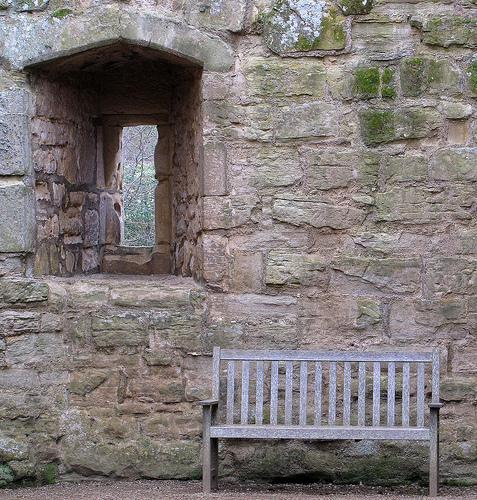Question: what is on the building?
Choices:
A. Ivy.
B. Roses.
C. Moss.
D. Lizards.
Answer with the letter. Answer: C Question: what is on the ground?
Choices:
A. Litter.
B. Pebbles.
C. Leaves.
D. Grass.
Answer with the letter. Answer: B Question: how does this building appear?
Choices:
A. Demolished.
B. Brand new.
C. Old.
D. Under construction.
Answer with the letter. Answer: C Question: how does this bench appear?
Choices:
A. Wet.
B. Dirty.
C. Dry.
D. Occupied.
Answer with the letter. Answer: B Question: where is this bench?
Choices:
A. In a park.
B. In a gymnasium.
C. On the ground.
D. Under a tree.
Answer with the letter. Answer: C Question: how does the ground appear?
Choices:
A. Wet.
B. Dirty.
C. Dry.
D. Cold.
Answer with the letter. Answer: B 